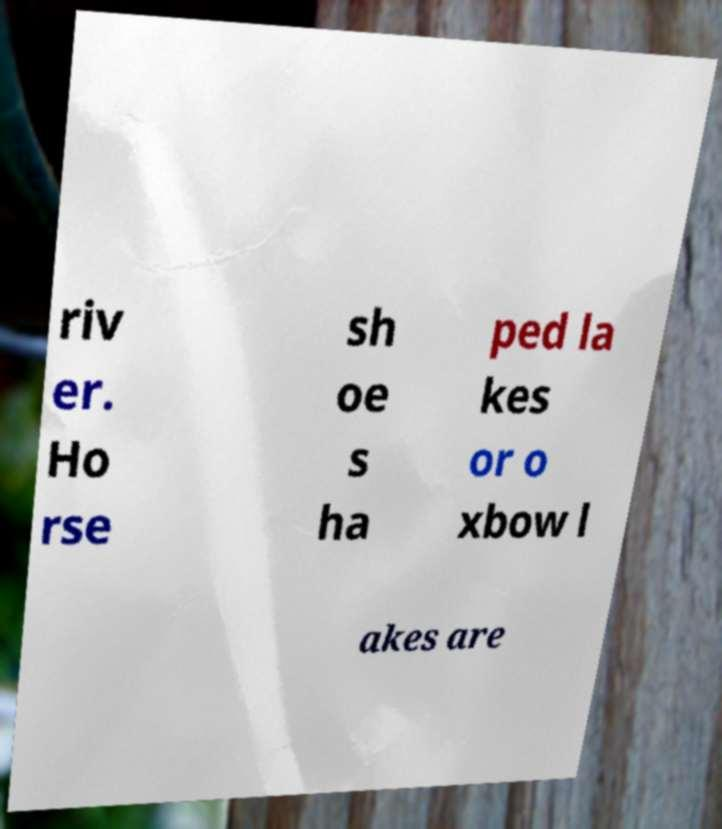For documentation purposes, I need the text within this image transcribed. Could you provide that? riv er. Ho rse sh oe s ha ped la kes or o xbow l akes are 